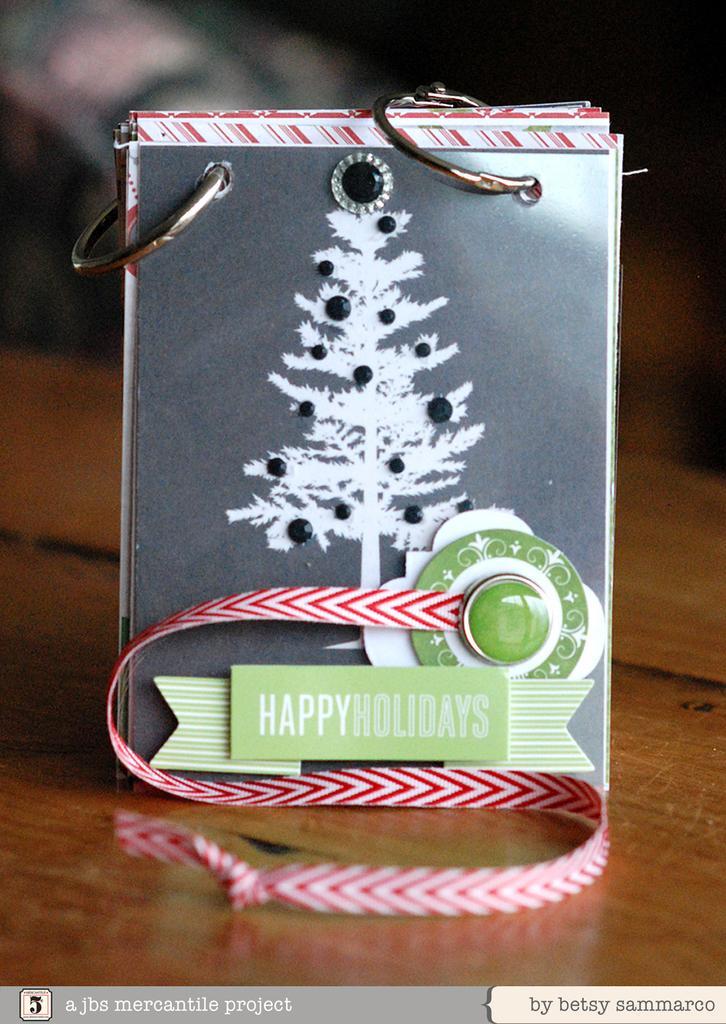Please provide a concise description of this image. We can see board with decorative items on the wooden surface,on this board we can see tree. In the background it is dark. At the bottom of the image we can see text. 